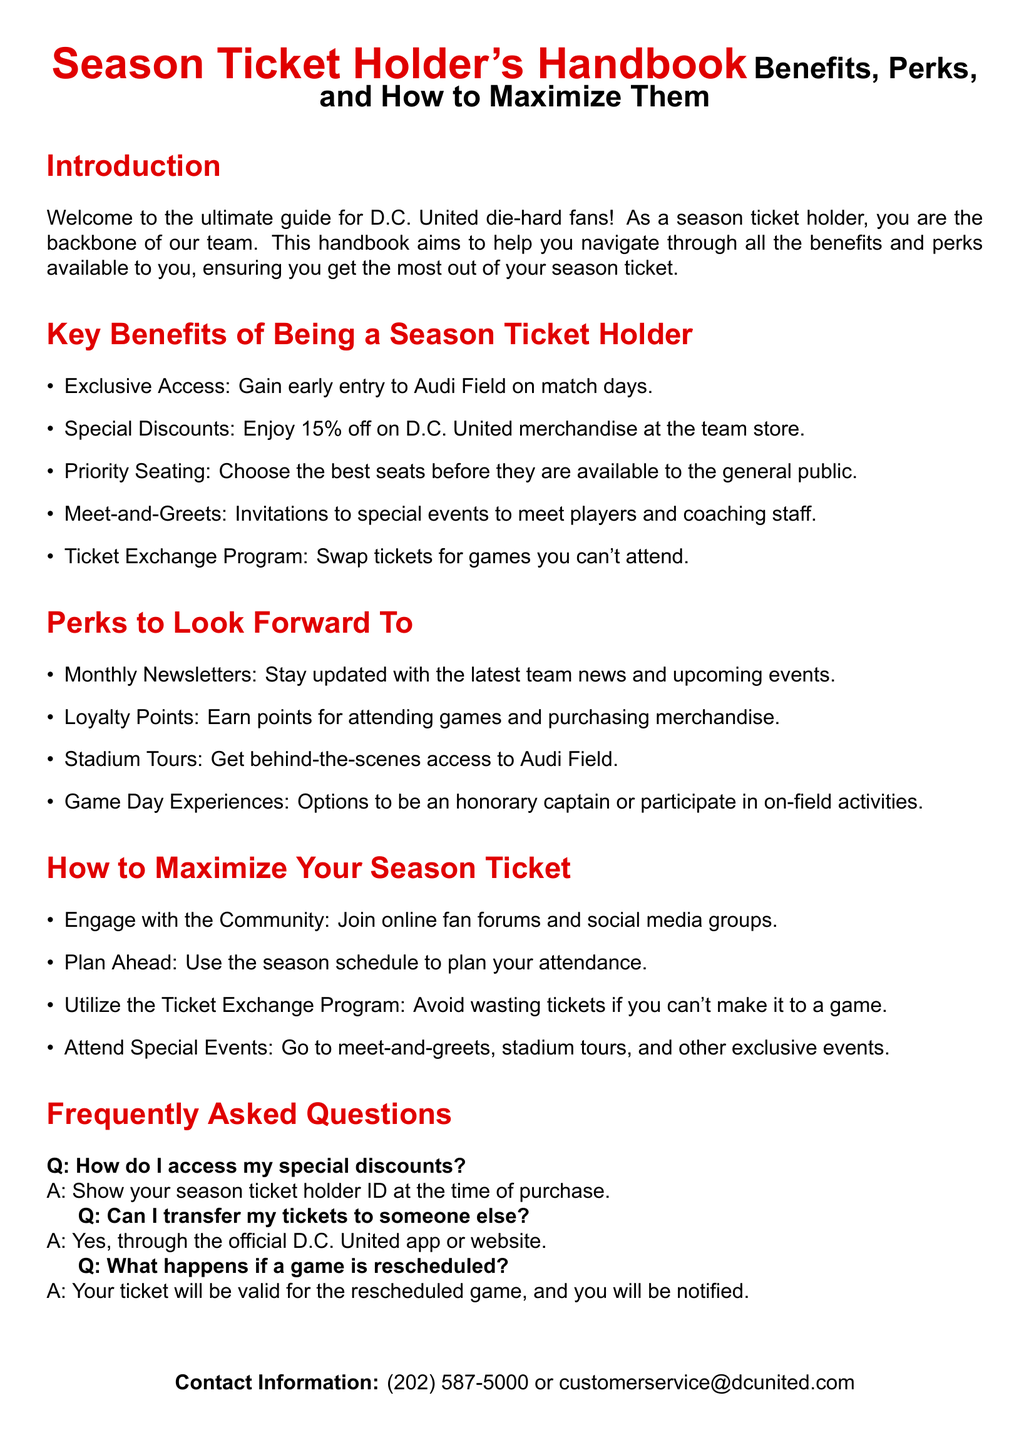What is the discount percentage for D.C. United merchandise? The discount for D.C. United merchandise is specified in the document, which states 15%.
Answer: 15% What should you show to access special discounts? The document states that you must show your season ticket holder ID at the time of purchase.
Answer: season ticket holder ID What is one of the exclusive events for season ticket holders? The document mentions “Meet-and-Greets” as one of the exclusive events for season ticket holders.
Answer: Meet-and-Greets How are season ticket holders notified about rescheduled games? According to the document, season ticket holders will be notified regarding rescheduled games.
Answer: notified What is the benefit of loyalty points? The document states that loyalty points are earned for attending games and purchasing merchandise.
Answer: Earn points What is the purpose of the Ticket Exchange Program? The document explains that the Ticket Exchange Program allows holders to swap tickets for games they can't attend.
Answer: swap tickets How can season ticket holders maximize their experience? The document lists engaging with the community as one way to maximize the season ticket experience.
Answer: Engage with the Community What is the main purpose of the handbook? The document clearly states that the assistance for navigating benefits and perks is the handbook's main purpose.
Answer: Navigate benefits and perks 